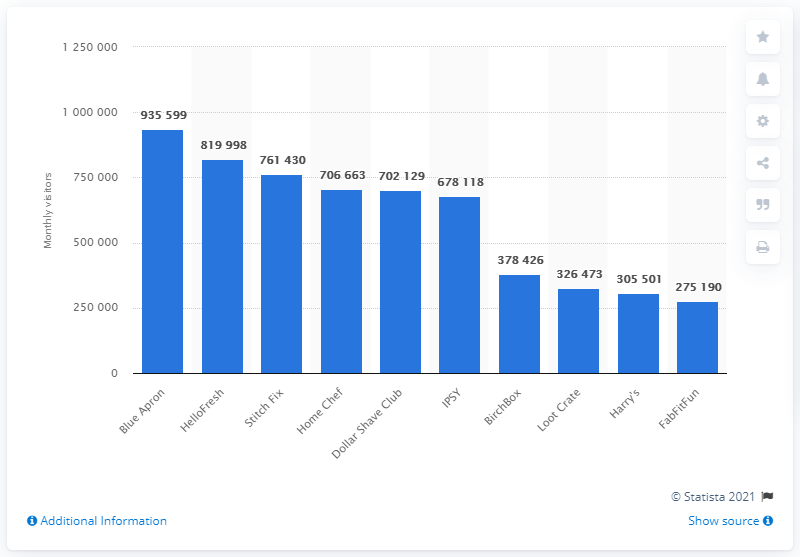Identify some key points in this picture. In April 2018, Blue Apron was the subscription box service with the most site visitors, making it the leading meal kit provider. 